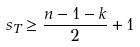Convert formula to latex. <formula><loc_0><loc_0><loc_500><loc_500>s _ { T } \geq \frac { n - 1 - k } { 2 } + 1</formula> 